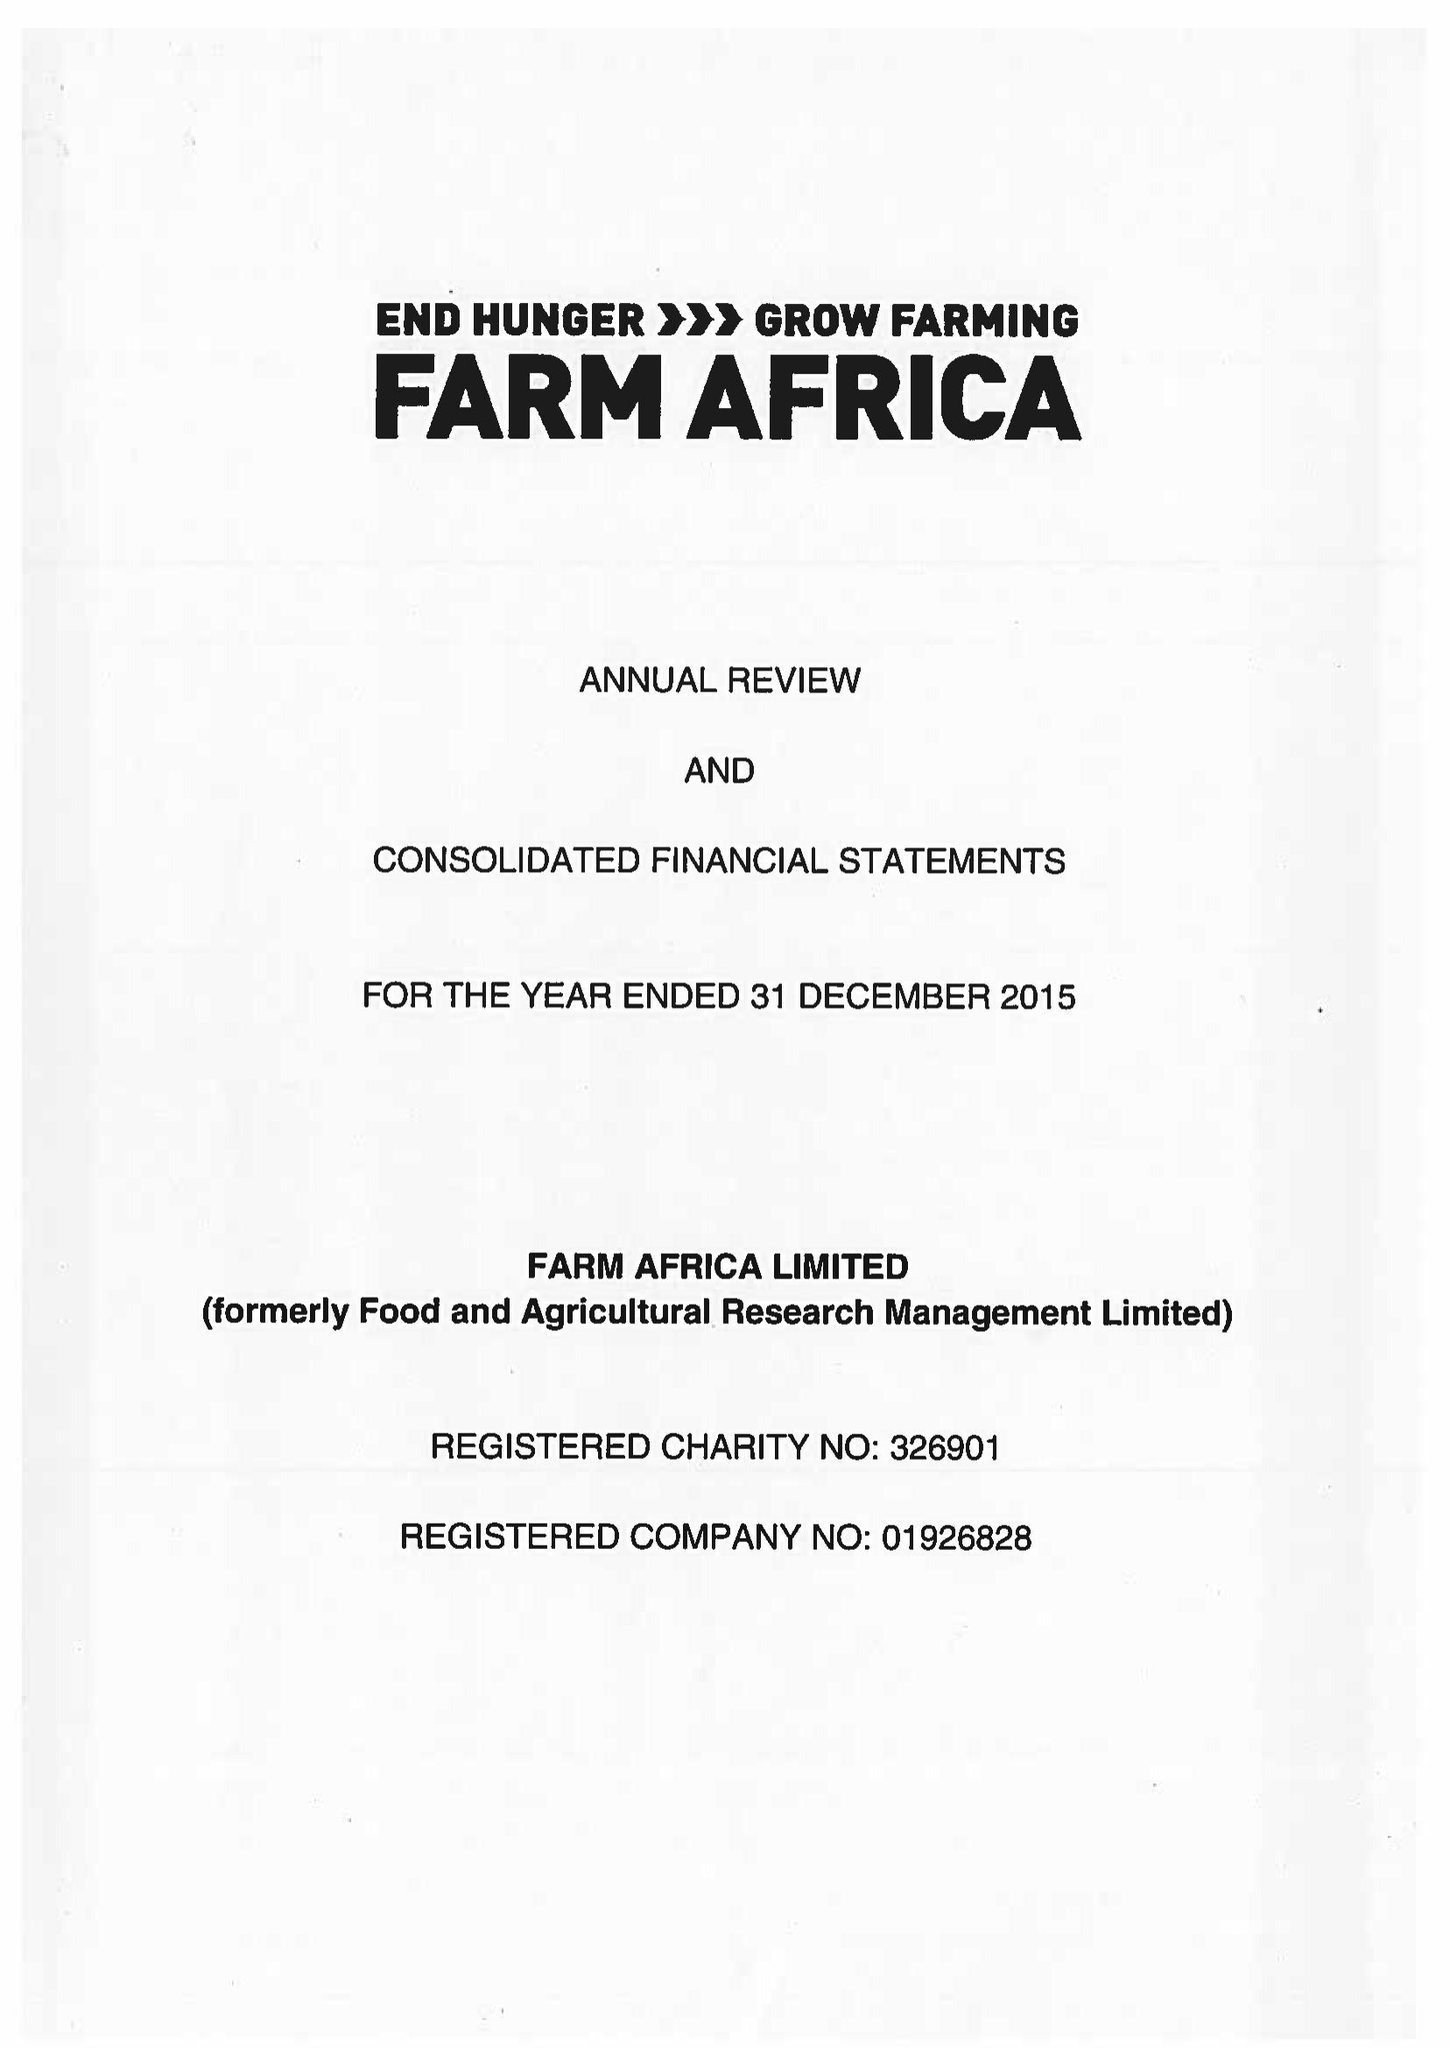What is the value for the income_annually_in_british_pounds?
Answer the question using a single word or phrase. 12145000.00 